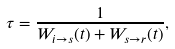Convert formula to latex. <formula><loc_0><loc_0><loc_500><loc_500>\tau = \frac { 1 } { W _ { i \rightarrow s } ( t ) + W _ { s \rightarrow r } ( t ) } ,</formula> 